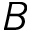Convert formula to latex. <formula><loc_0><loc_0><loc_500><loc_500>B</formula> 